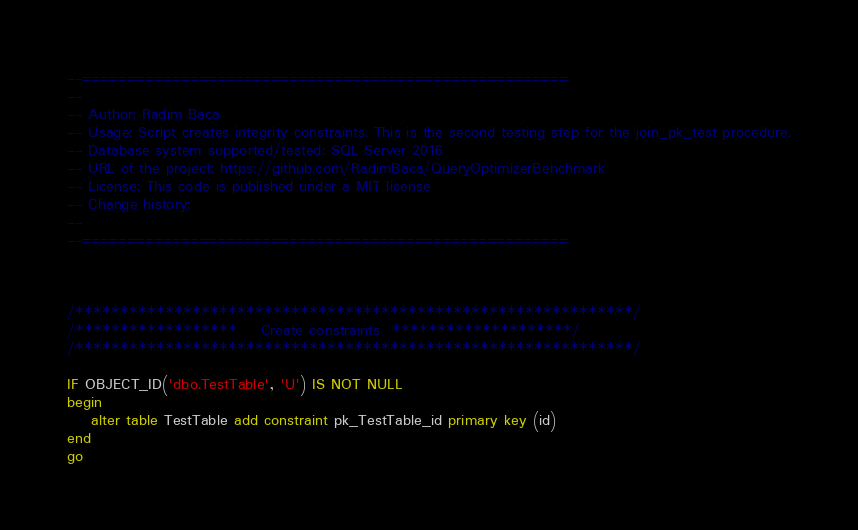Convert code to text. <code><loc_0><loc_0><loc_500><loc_500><_SQL_>--======================================================
--
-- Author: Radim Baca
-- Usage: Script creates integrity constraints. This is the second testing step for the join_pk_test procedure.
-- Database system supported/tested: SQL Server 2016
-- URL of the project: https://github.com/RadimBaca/QueryOptimizerBenchmark
-- License: This code is published under a MIT license
-- Change history:
--
--======================================================



/**************************************************************/
/******************    Create constraints  ********************/
/**************************************************************/

IF OBJECT_ID('dbo.TestTable', 'U') IS NOT NULL  
begin
	alter table TestTable add constraint pk_TestTable_id primary key (id)
end
go


</code> 